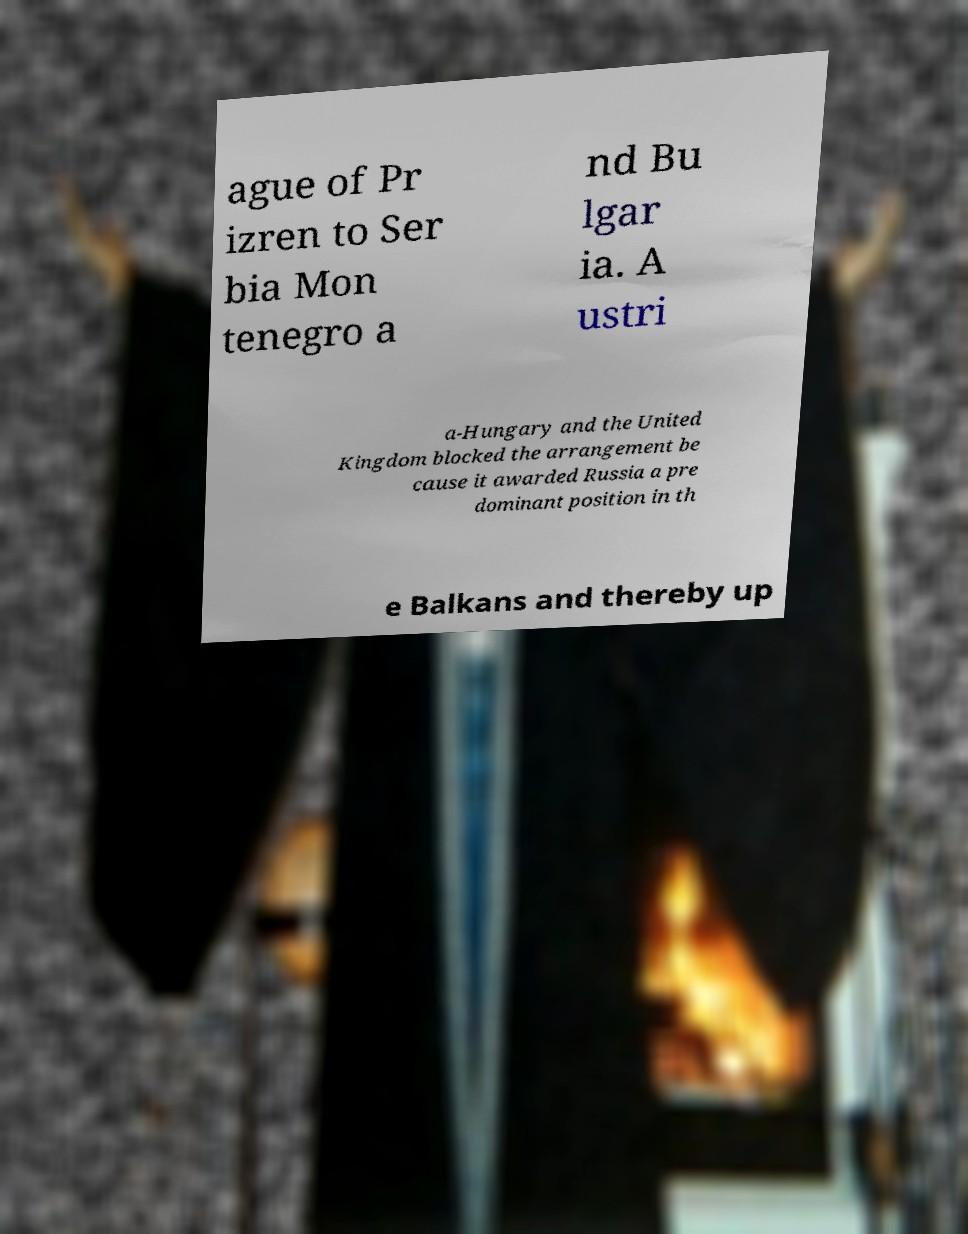Could you extract and type out the text from this image? ague of Pr izren to Ser bia Mon tenegro a nd Bu lgar ia. A ustri a-Hungary and the United Kingdom blocked the arrangement be cause it awarded Russia a pre dominant position in th e Balkans and thereby up 